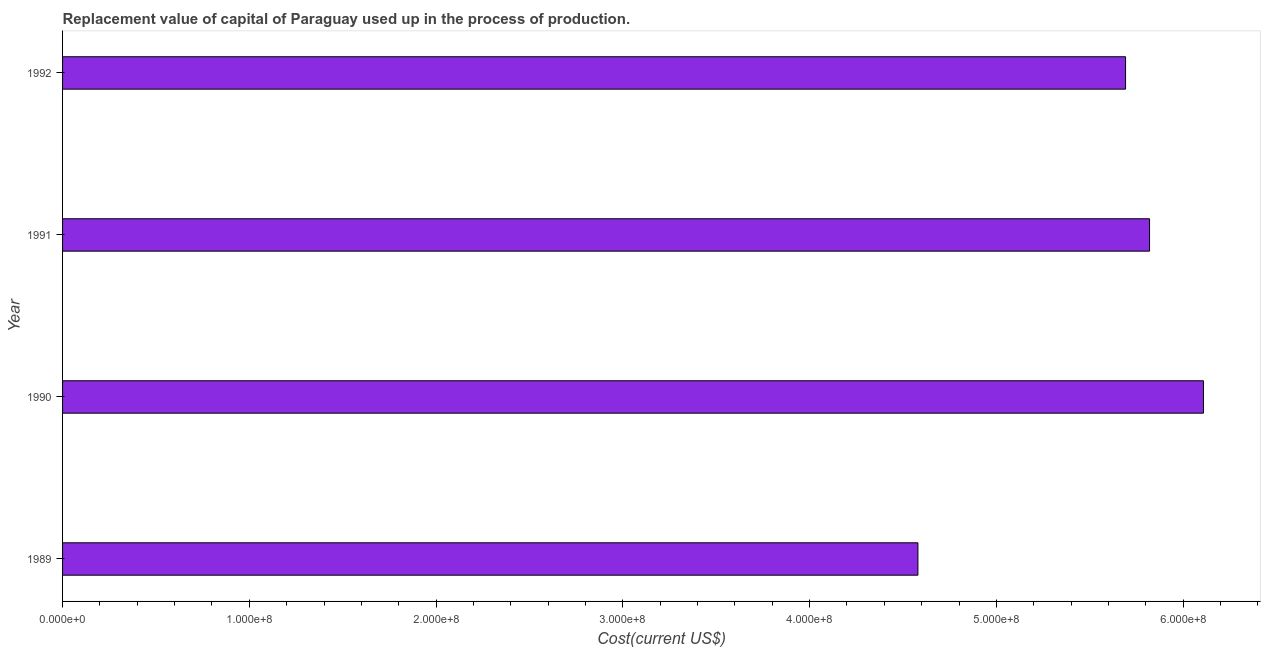Does the graph contain any zero values?
Your response must be concise. No. What is the title of the graph?
Your response must be concise. Replacement value of capital of Paraguay used up in the process of production. What is the label or title of the X-axis?
Keep it short and to the point. Cost(current US$). What is the consumption of fixed capital in 1991?
Provide a short and direct response. 5.82e+08. Across all years, what is the maximum consumption of fixed capital?
Keep it short and to the point. 6.11e+08. Across all years, what is the minimum consumption of fixed capital?
Offer a very short reply. 4.58e+08. In which year was the consumption of fixed capital maximum?
Make the answer very short. 1990. What is the sum of the consumption of fixed capital?
Ensure brevity in your answer.  2.22e+09. What is the difference between the consumption of fixed capital in 1990 and 1992?
Offer a very short reply. 4.17e+07. What is the average consumption of fixed capital per year?
Provide a succinct answer. 5.55e+08. What is the median consumption of fixed capital?
Provide a succinct answer. 5.76e+08. In how many years, is the consumption of fixed capital greater than 360000000 US$?
Make the answer very short. 4. Do a majority of the years between 1991 and 1992 (inclusive) have consumption of fixed capital greater than 200000000 US$?
Your answer should be very brief. Yes. What is the ratio of the consumption of fixed capital in 1989 to that in 1991?
Give a very brief answer. 0.79. Is the consumption of fixed capital in 1991 less than that in 1992?
Keep it short and to the point. No. What is the difference between the highest and the second highest consumption of fixed capital?
Make the answer very short. 2.89e+07. Is the sum of the consumption of fixed capital in 1989 and 1990 greater than the maximum consumption of fixed capital across all years?
Provide a succinct answer. Yes. What is the difference between the highest and the lowest consumption of fixed capital?
Keep it short and to the point. 1.53e+08. In how many years, is the consumption of fixed capital greater than the average consumption of fixed capital taken over all years?
Offer a very short reply. 3. How many bars are there?
Provide a short and direct response. 4. Are all the bars in the graph horizontal?
Keep it short and to the point. Yes. How many years are there in the graph?
Give a very brief answer. 4. What is the Cost(current US$) in 1989?
Ensure brevity in your answer.  4.58e+08. What is the Cost(current US$) of 1990?
Your answer should be very brief. 6.11e+08. What is the Cost(current US$) of 1991?
Keep it short and to the point. 5.82e+08. What is the Cost(current US$) of 1992?
Your response must be concise. 5.69e+08. What is the difference between the Cost(current US$) in 1989 and 1990?
Your answer should be compact. -1.53e+08. What is the difference between the Cost(current US$) in 1989 and 1991?
Provide a succinct answer. -1.24e+08. What is the difference between the Cost(current US$) in 1989 and 1992?
Provide a succinct answer. -1.11e+08. What is the difference between the Cost(current US$) in 1990 and 1991?
Ensure brevity in your answer.  2.89e+07. What is the difference between the Cost(current US$) in 1990 and 1992?
Your answer should be compact. 4.17e+07. What is the difference between the Cost(current US$) in 1991 and 1992?
Make the answer very short. 1.28e+07. What is the ratio of the Cost(current US$) in 1989 to that in 1990?
Ensure brevity in your answer.  0.75. What is the ratio of the Cost(current US$) in 1989 to that in 1991?
Your response must be concise. 0.79. What is the ratio of the Cost(current US$) in 1989 to that in 1992?
Ensure brevity in your answer.  0.81. What is the ratio of the Cost(current US$) in 1990 to that in 1992?
Offer a very short reply. 1.07. 